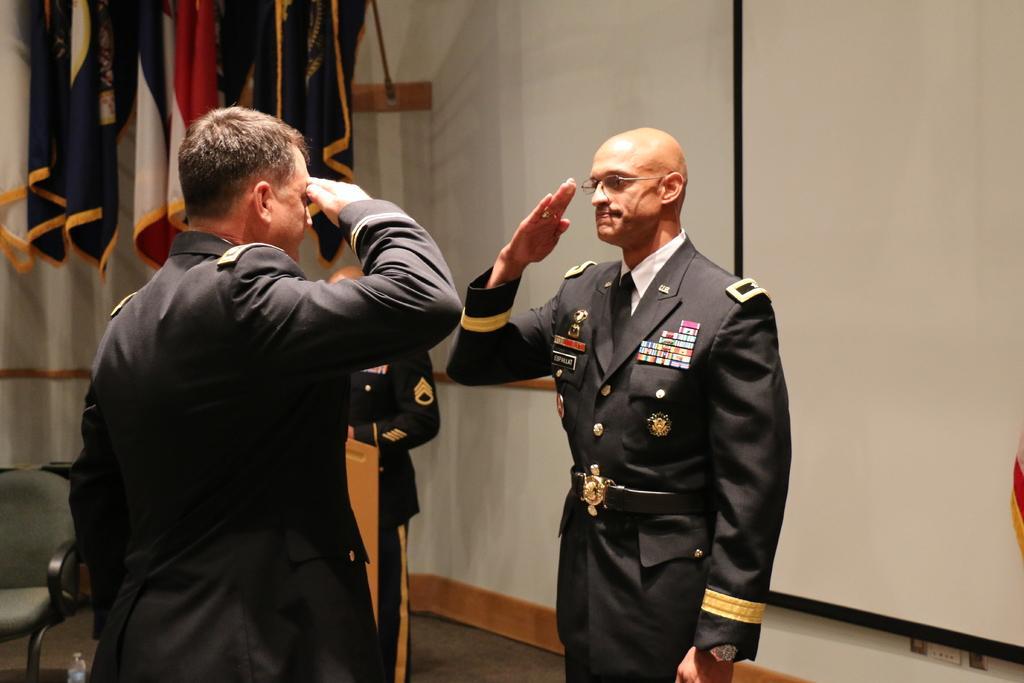Please provide a concise description of this image. In the foreground of the picture there are two soldiers. In the center of the picture there is a soldier in front of a podium. On the left there is a chair. At the top left there are flags. On the right there is a projector screen. In the center of the background it is well. 